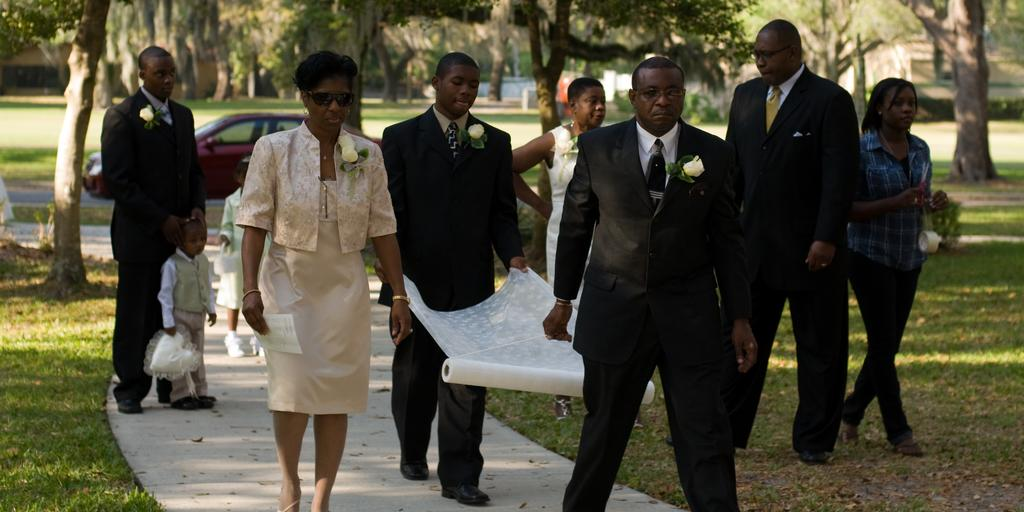What is happening in the image involving people? There are people standing in the image. What are the two men doing in the image? Two men are carrying a cloth in the image. What can be seen in the background of the image? There is a car on a road and trees in the background of the image. What type of park can be seen in the image? There is no park present in the image. How quiet is the environment in the image? The provided facts do not give any information about the noise level in the image, so it cannot be determined from the image. 